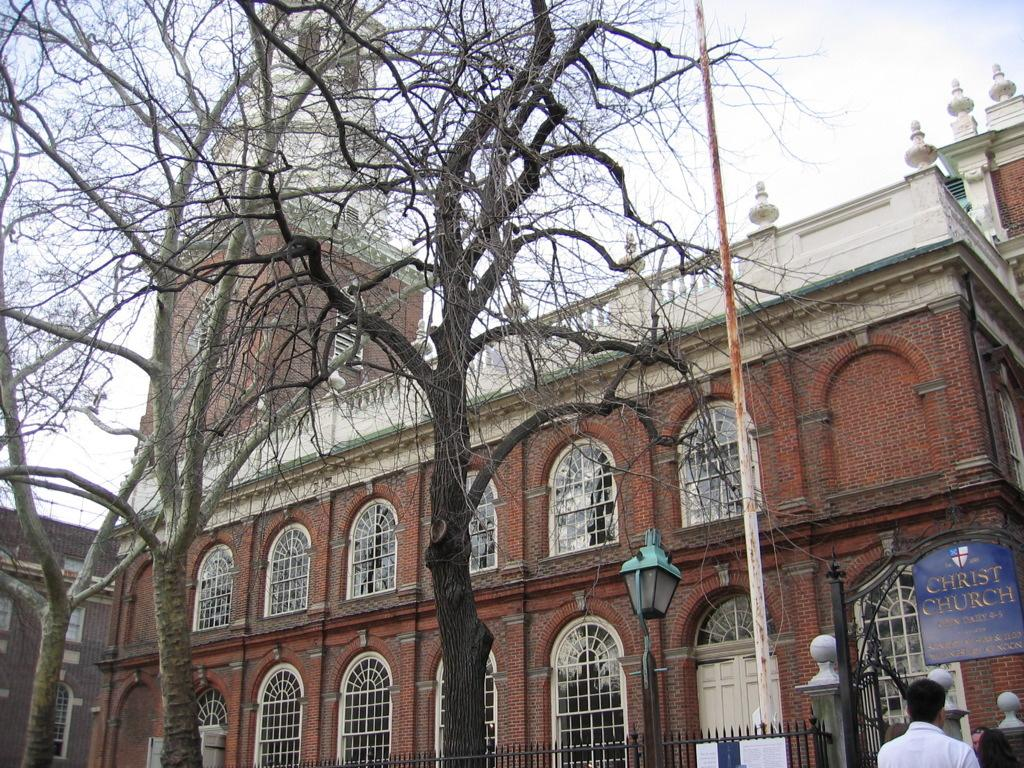What type of building is in the image? There is a church building in the image. How can the church building be identified? The church building has a name board. What type of lighting is present in the image? There are lamp posts in the image. What type of fence surrounds the church building? There is a metal rod fence in the image. What type of vegetation is in the image? There are trees in the image. What type of entrance is present in the image? There is a metal gate in the image. What other metal object is present in the image? There is a metal rod in the image. Is there anyone near the church building? Yes, there is a person in front of the church building. What type of brick is used to construct the division between the trees in the image? There is no division between the trees in the image, and no bricks are mentioned in the provided facts. 